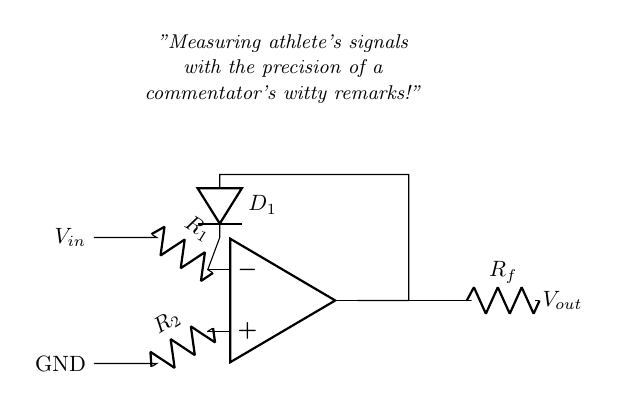What is the function of the op-amp in this circuit? The op-amp functions as a precision rectifier to accurately measure input signals without significant voltage drop.
Answer: Precision rectifier What types of resistors are used in the circuit? The circuit utilizes two resistors labeled R1 and R2, which are in series with the input signals at the op-amp terminals.
Answer: R1 and R2 How many diodes are present in this rectifier circuit? There is one diode, labeled D1, that is used for the rectification process.
Answer: One What does the output voltage represent in this circuit? The output voltage, denoted as Vout, represents the rectified signal that correlates to the athlete's biometric data being measured.
Answer: Biometric signal What are the input and ground connections labeled as? The input connection is labeled Vin and the ground connection is labeled as GND in the circuit diagram.
Answer: Vin and GND What is the primary application of this precision rectifier circuit? The primary application is for real-time measurement of athletes' biometric signals, ensuring accuracy and precision.
Answer: Measuring biometric signals 